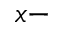Convert formula to latex. <formula><loc_0><loc_0><loc_500><loc_500>x -</formula> 